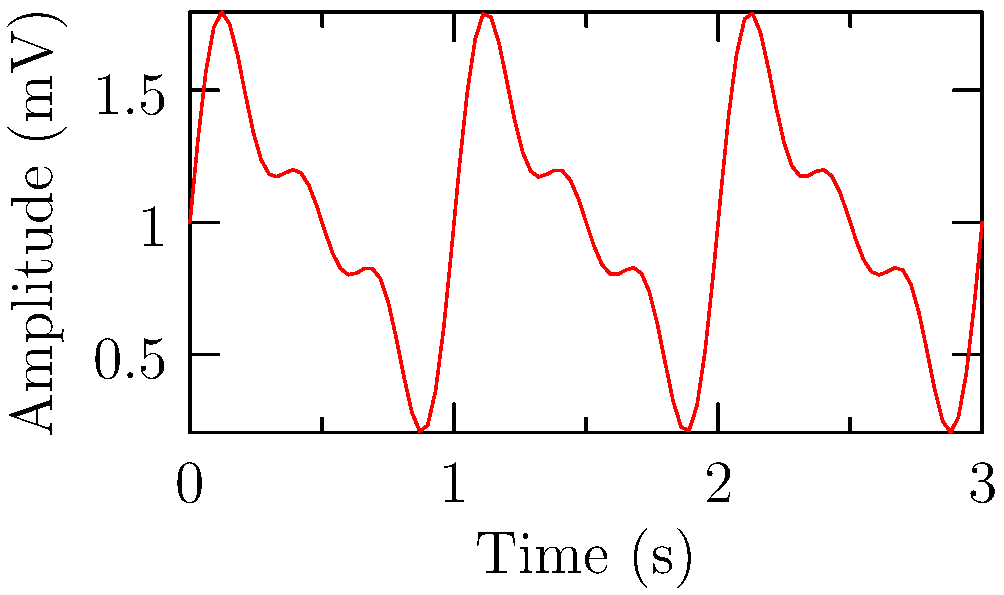Based on the ECG waveform shown, which represents a 3-second recording, what is the approximate heart rate in beats per minute (BPM)? To calculate the heart rate from an ECG waveform:

1. Identify R-R intervals: The distance between two consecutive R peaks represents one heartbeat. In this graph, we see two clear R peaks.

2. Calculate the time between R peaks: The waveform shows 3 seconds of data, and there are two R peaks, so the R-R interval is:

   $\text{R-R interval} = 3 \text{ seconds} / 1 \text{ beat} = 3 \text{ seconds/beat}$

3. Convert to beats per minute:
   
   $\text{Heart rate} = \frac{60 \text{ seconds/minute}}{\text{R-R interval in seconds/beat}}$

   $\text{Heart rate} = \frac{60 \text{ seconds/minute}}{3 \text{ seconds/beat}} = 20 \text{ beats/minute}$

Therefore, the approximate heart rate shown in this ECG waveform is 20 BPM.

Note: This is an unusually low heart rate (bradycardia) and would be concerning in most clinical situations, potentially related to the patient's chronic condition.
Answer: 20 BPM 